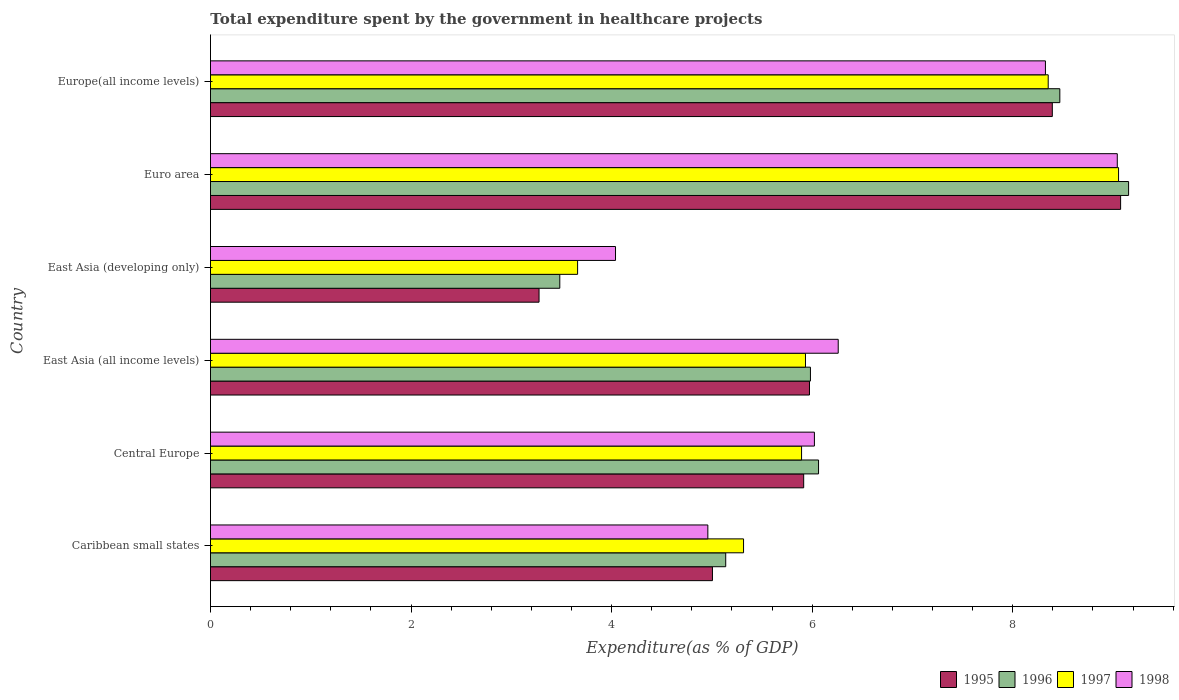How many different coloured bars are there?
Your answer should be very brief. 4. How many groups of bars are there?
Provide a short and direct response. 6. Are the number of bars per tick equal to the number of legend labels?
Your answer should be compact. Yes. How many bars are there on the 4th tick from the top?
Your answer should be very brief. 4. What is the label of the 5th group of bars from the top?
Offer a very short reply. Central Europe. In how many cases, is the number of bars for a given country not equal to the number of legend labels?
Your answer should be compact. 0. What is the total expenditure spent by the government in healthcare projects in 1998 in Euro area?
Give a very brief answer. 9.04. Across all countries, what is the maximum total expenditure spent by the government in healthcare projects in 1995?
Ensure brevity in your answer.  9.08. Across all countries, what is the minimum total expenditure spent by the government in healthcare projects in 1998?
Your response must be concise. 4.04. In which country was the total expenditure spent by the government in healthcare projects in 1995 maximum?
Provide a short and direct response. Euro area. In which country was the total expenditure spent by the government in healthcare projects in 1996 minimum?
Keep it short and to the point. East Asia (developing only). What is the total total expenditure spent by the government in healthcare projects in 1997 in the graph?
Offer a terse response. 38.21. What is the difference between the total expenditure spent by the government in healthcare projects in 1997 in Caribbean small states and that in East Asia (all income levels)?
Provide a short and direct response. -0.62. What is the difference between the total expenditure spent by the government in healthcare projects in 1995 in Central Europe and the total expenditure spent by the government in healthcare projects in 1996 in Europe(all income levels)?
Your answer should be compact. -2.55. What is the average total expenditure spent by the government in healthcare projects in 1996 per country?
Offer a terse response. 6.38. What is the difference between the total expenditure spent by the government in healthcare projects in 1995 and total expenditure spent by the government in healthcare projects in 1998 in East Asia (developing only)?
Provide a succinct answer. -0.76. What is the ratio of the total expenditure spent by the government in healthcare projects in 1996 in Central Europe to that in Euro area?
Your response must be concise. 0.66. What is the difference between the highest and the second highest total expenditure spent by the government in healthcare projects in 1997?
Offer a very short reply. 0.7. What is the difference between the highest and the lowest total expenditure spent by the government in healthcare projects in 1995?
Offer a very short reply. 5.8. In how many countries, is the total expenditure spent by the government in healthcare projects in 1995 greater than the average total expenditure spent by the government in healthcare projects in 1995 taken over all countries?
Provide a succinct answer. 2. What does the 4th bar from the top in East Asia (all income levels) represents?
Your answer should be compact. 1995. What does the 4th bar from the bottom in East Asia (all income levels) represents?
Your answer should be very brief. 1998. Does the graph contain grids?
Your answer should be very brief. No. Where does the legend appear in the graph?
Provide a short and direct response. Bottom right. How are the legend labels stacked?
Offer a very short reply. Horizontal. What is the title of the graph?
Your response must be concise. Total expenditure spent by the government in healthcare projects. What is the label or title of the X-axis?
Your response must be concise. Expenditure(as % of GDP). What is the Expenditure(as % of GDP) in 1995 in Caribbean small states?
Ensure brevity in your answer.  5.01. What is the Expenditure(as % of GDP) of 1996 in Caribbean small states?
Give a very brief answer. 5.14. What is the Expenditure(as % of GDP) of 1997 in Caribbean small states?
Give a very brief answer. 5.32. What is the Expenditure(as % of GDP) in 1998 in Caribbean small states?
Offer a terse response. 4.96. What is the Expenditure(as % of GDP) in 1995 in Central Europe?
Keep it short and to the point. 5.92. What is the Expenditure(as % of GDP) of 1996 in Central Europe?
Give a very brief answer. 6.06. What is the Expenditure(as % of GDP) in 1997 in Central Europe?
Offer a terse response. 5.89. What is the Expenditure(as % of GDP) of 1998 in Central Europe?
Make the answer very short. 6.02. What is the Expenditure(as % of GDP) of 1995 in East Asia (all income levels)?
Your response must be concise. 5.97. What is the Expenditure(as % of GDP) of 1996 in East Asia (all income levels)?
Make the answer very short. 5.98. What is the Expenditure(as % of GDP) of 1997 in East Asia (all income levels)?
Give a very brief answer. 5.93. What is the Expenditure(as % of GDP) of 1998 in East Asia (all income levels)?
Provide a succinct answer. 6.26. What is the Expenditure(as % of GDP) of 1995 in East Asia (developing only)?
Your answer should be compact. 3.28. What is the Expenditure(as % of GDP) of 1996 in East Asia (developing only)?
Offer a very short reply. 3.48. What is the Expenditure(as % of GDP) in 1997 in East Asia (developing only)?
Your answer should be very brief. 3.66. What is the Expenditure(as % of GDP) of 1998 in East Asia (developing only)?
Your answer should be very brief. 4.04. What is the Expenditure(as % of GDP) in 1995 in Euro area?
Make the answer very short. 9.08. What is the Expenditure(as % of GDP) of 1996 in Euro area?
Provide a short and direct response. 9.16. What is the Expenditure(as % of GDP) in 1997 in Euro area?
Ensure brevity in your answer.  9.06. What is the Expenditure(as % of GDP) in 1998 in Euro area?
Give a very brief answer. 9.04. What is the Expenditure(as % of GDP) of 1995 in Europe(all income levels)?
Offer a very short reply. 8.39. What is the Expenditure(as % of GDP) in 1996 in Europe(all income levels)?
Give a very brief answer. 8.47. What is the Expenditure(as % of GDP) in 1997 in Europe(all income levels)?
Offer a terse response. 8.35. What is the Expenditure(as % of GDP) of 1998 in Europe(all income levels)?
Your response must be concise. 8.33. Across all countries, what is the maximum Expenditure(as % of GDP) in 1995?
Provide a short and direct response. 9.08. Across all countries, what is the maximum Expenditure(as % of GDP) in 1996?
Your response must be concise. 9.16. Across all countries, what is the maximum Expenditure(as % of GDP) in 1997?
Your response must be concise. 9.06. Across all countries, what is the maximum Expenditure(as % of GDP) in 1998?
Offer a very short reply. 9.04. Across all countries, what is the minimum Expenditure(as % of GDP) of 1995?
Offer a very short reply. 3.28. Across all countries, what is the minimum Expenditure(as % of GDP) in 1996?
Provide a short and direct response. 3.48. Across all countries, what is the minimum Expenditure(as % of GDP) in 1997?
Provide a succinct answer. 3.66. Across all countries, what is the minimum Expenditure(as % of GDP) in 1998?
Offer a very short reply. 4.04. What is the total Expenditure(as % of GDP) of 1995 in the graph?
Offer a terse response. 37.64. What is the total Expenditure(as % of GDP) in 1996 in the graph?
Your response must be concise. 38.29. What is the total Expenditure(as % of GDP) in 1997 in the graph?
Your answer should be very brief. 38.21. What is the total Expenditure(as % of GDP) of 1998 in the graph?
Offer a terse response. 38.65. What is the difference between the Expenditure(as % of GDP) in 1995 in Caribbean small states and that in Central Europe?
Provide a short and direct response. -0.91. What is the difference between the Expenditure(as % of GDP) of 1996 in Caribbean small states and that in Central Europe?
Ensure brevity in your answer.  -0.93. What is the difference between the Expenditure(as % of GDP) of 1997 in Caribbean small states and that in Central Europe?
Ensure brevity in your answer.  -0.58. What is the difference between the Expenditure(as % of GDP) in 1998 in Caribbean small states and that in Central Europe?
Ensure brevity in your answer.  -1.06. What is the difference between the Expenditure(as % of GDP) in 1995 in Caribbean small states and that in East Asia (all income levels)?
Provide a short and direct response. -0.97. What is the difference between the Expenditure(as % of GDP) in 1996 in Caribbean small states and that in East Asia (all income levels)?
Give a very brief answer. -0.84. What is the difference between the Expenditure(as % of GDP) of 1997 in Caribbean small states and that in East Asia (all income levels)?
Your answer should be compact. -0.62. What is the difference between the Expenditure(as % of GDP) of 1998 in Caribbean small states and that in East Asia (all income levels)?
Offer a very short reply. -1.3. What is the difference between the Expenditure(as % of GDP) of 1995 in Caribbean small states and that in East Asia (developing only)?
Provide a short and direct response. 1.73. What is the difference between the Expenditure(as % of GDP) in 1996 in Caribbean small states and that in East Asia (developing only)?
Your answer should be compact. 1.65. What is the difference between the Expenditure(as % of GDP) in 1997 in Caribbean small states and that in East Asia (developing only)?
Ensure brevity in your answer.  1.65. What is the difference between the Expenditure(as % of GDP) in 1998 in Caribbean small states and that in East Asia (developing only)?
Make the answer very short. 0.92. What is the difference between the Expenditure(as % of GDP) of 1995 in Caribbean small states and that in Euro area?
Your response must be concise. -4.07. What is the difference between the Expenditure(as % of GDP) of 1996 in Caribbean small states and that in Euro area?
Your response must be concise. -4.02. What is the difference between the Expenditure(as % of GDP) of 1997 in Caribbean small states and that in Euro area?
Ensure brevity in your answer.  -3.74. What is the difference between the Expenditure(as % of GDP) of 1998 in Caribbean small states and that in Euro area?
Keep it short and to the point. -4.08. What is the difference between the Expenditure(as % of GDP) of 1995 in Caribbean small states and that in Europe(all income levels)?
Give a very brief answer. -3.39. What is the difference between the Expenditure(as % of GDP) in 1996 in Caribbean small states and that in Europe(all income levels)?
Give a very brief answer. -3.33. What is the difference between the Expenditure(as % of GDP) of 1997 in Caribbean small states and that in Europe(all income levels)?
Provide a succinct answer. -3.04. What is the difference between the Expenditure(as % of GDP) in 1998 in Caribbean small states and that in Europe(all income levels)?
Give a very brief answer. -3.37. What is the difference between the Expenditure(as % of GDP) of 1995 in Central Europe and that in East Asia (all income levels)?
Your answer should be very brief. -0.06. What is the difference between the Expenditure(as % of GDP) in 1996 in Central Europe and that in East Asia (all income levels)?
Offer a very short reply. 0.08. What is the difference between the Expenditure(as % of GDP) of 1997 in Central Europe and that in East Asia (all income levels)?
Give a very brief answer. -0.04. What is the difference between the Expenditure(as % of GDP) of 1998 in Central Europe and that in East Asia (all income levels)?
Provide a short and direct response. -0.24. What is the difference between the Expenditure(as % of GDP) of 1995 in Central Europe and that in East Asia (developing only)?
Offer a very short reply. 2.64. What is the difference between the Expenditure(as % of GDP) in 1996 in Central Europe and that in East Asia (developing only)?
Ensure brevity in your answer.  2.58. What is the difference between the Expenditure(as % of GDP) of 1997 in Central Europe and that in East Asia (developing only)?
Provide a short and direct response. 2.23. What is the difference between the Expenditure(as % of GDP) of 1998 in Central Europe and that in East Asia (developing only)?
Provide a short and direct response. 1.98. What is the difference between the Expenditure(as % of GDP) in 1995 in Central Europe and that in Euro area?
Offer a very short reply. -3.16. What is the difference between the Expenditure(as % of GDP) in 1996 in Central Europe and that in Euro area?
Offer a very short reply. -3.09. What is the difference between the Expenditure(as % of GDP) in 1997 in Central Europe and that in Euro area?
Keep it short and to the point. -3.16. What is the difference between the Expenditure(as % of GDP) in 1998 in Central Europe and that in Euro area?
Your answer should be compact. -3.02. What is the difference between the Expenditure(as % of GDP) of 1995 in Central Europe and that in Europe(all income levels)?
Provide a short and direct response. -2.48. What is the difference between the Expenditure(as % of GDP) in 1996 in Central Europe and that in Europe(all income levels)?
Your answer should be compact. -2.41. What is the difference between the Expenditure(as % of GDP) in 1997 in Central Europe and that in Europe(all income levels)?
Offer a very short reply. -2.46. What is the difference between the Expenditure(as % of GDP) in 1998 in Central Europe and that in Europe(all income levels)?
Give a very brief answer. -2.3. What is the difference between the Expenditure(as % of GDP) of 1995 in East Asia (all income levels) and that in East Asia (developing only)?
Provide a short and direct response. 2.7. What is the difference between the Expenditure(as % of GDP) in 1996 in East Asia (all income levels) and that in East Asia (developing only)?
Offer a very short reply. 2.5. What is the difference between the Expenditure(as % of GDP) of 1997 in East Asia (all income levels) and that in East Asia (developing only)?
Your answer should be very brief. 2.27. What is the difference between the Expenditure(as % of GDP) of 1998 in East Asia (all income levels) and that in East Asia (developing only)?
Give a very brief answer. 2.22. What is the difference between the Expenditure(as % of GDP) of 1995 in East Asia (all income levels) and that in Euro area?
Your response must be concise. -3.1. What is the difference between the Expenditure(as % of GDP) in 1996 in East Asia (all income levels) and that in Euro area?
Offer a very short reply. -3.17. What is the difference between the Expenditure(as % of GDP) of 1997 in East Asia (all income levels) and that in Euro area?
Provide a short and direct response. -3.12. What is the difference between the Expenditure(as % of GDP) of 1998 in East Asia (all income levels) and that in Euro area?
Ensure brevity in your answer.  -2.78. What is the difference between the Expenditure(as % of GDP) in 1995 in East Asia (all income levels) and that in Europe(all income levels)?
Give a very brief answer. -2.42. What is the difference between the Expenditure(as % of GDP) of 1996 in East Asia (all income levels) and that in Europe(all income levels)?
Offer a terse response. -2.49. What is the difference between the Expenditure(as % of GDP) in 1997 in East Asia (all income levels) and that in Europe(all income levels)?
Offer a terse response. -2.42. What is the difference between the Expenditure(as % of GDP) of 1998 in East Asia (all income levels) and that in Europe(all income levels)?
Your answer should be compact. -2.07. What is the difference between the Expenditure(as % of GDP) in 1995 in East Asia (developing only) and that in Euro area?
Ensure brevity in your answer.  -5.8. What is the difference between the Expenditure(as % of GDP) in 1996 in East Asia (developing only) and that in Euro area?
Your answer should be compact. -5.67. What is the difference between the Expenditure(as % of GDP) of 1997 in East Asia (developing only) and that in Euro area?
Your response must be concise. -5.39. What is the difference between the Expenditure(as % of GDP) in 1998 in East Asia (developing only) and that in Euro area?
Provide a short and direct response. -5. What is the difference between the Expenditure(as % of GDP) of 1995 in East Asia (developing only) and that in Europe(all income levels)?
Give a very brief answer. -5.12. What is the difference between the Expenditure(as % of GDP) of 1996 in East Asia (developing only) and that in Europe(all income levels)?
Offer a very short reply. -4.99. What is the difference between the Expenditure(as % of GDP) in 1997 in East Asia (developing only) and that in Europe(all income levels)?
Keep it short and to the point. -4.69. What is the difference between the Expenditure(as % of GDP) in 1998 in East Asia (developing only) and that in Europe(all income levels)?
Offer a very short reply. -4.29. What is the difference between the Expenditure(as % of GDP) in 1995 in Euro area and that in Europe(all income levels)?
Your answer should be very brief. 0.68. What is the difference between the Expenditure(as % of GDP) in 1996 in Euro area and that in Europe(all income levels)?
Make the answer very short. 0.69. What is the difference between the Expenditure(as % of GDP) in 1997 in Euro area and that in Europe(all income levels)?
Offer a very short reply. 0.7. What is the difference between the Expenditure(as % of GDP) of 1998 in Euro area and that in Europe(all income levels)?
Provide a succinct answer. 0.72. What is the difference between the Expenditure(as % of GDP) of 1995 in Caribbean small states and the Expenditure(as % of GDP) of 1996 in Central Europe?
Provide a succinct answer. -1.06. What is the difference between the Expenditure(as % of GDP) of 1995 in Caribbean small states and the Expenditure(as % of GDP) of 1997 in Central Europe?
Make the answer very short. -0.89. What is the difference between the Expenditure(as % of GDP) in 1995 in Caribbean small states and the Expenditure(as % of GDP) in 1998 in Central Europe?
Offer a terse response. -1.02. What is the difference between the Expenditure(as % of GDP) in 1996 in Caribbean small states and the Expenditure(as % of GDP) in 1997 in Central Europe?
Provide a short and direct response. -0.76. What is the difference between the Expenditure(as % of GDP) of 1996 in Caribbean small states and the Expenditure(as % of GDP) of 1998 in Central Europe?
Make the answer very short. -0.88. What is the difference between the Expenditure(as % of GDP) in 1997 in Caribbean small states and the Expenditure(as % of GDP) in 1998 in Central Europe?
Offer a terse response. -0.71. What is the difference between the Expenditure(as % of GDP) of 1995 in Caribbean small states and the Expenditure(as % of GDP) of 1996 in East Asia (all income levels)?
Your answer should be very brief. -0.98. What is the difference between the Expenditure(as % of GDP) of 1995 in Caribbean small states and the Expenditure(as % of GDP) of 1997 in East Asia (all income levels)?
Provide a short and direct response. -0.93. What is the difference between the Expenditure(as % of GDP) of 1995 in Caribbean small states and the Expenditure(as % of GDP) of 1998 in East Asia (all income levels)?
Ensure brevity in your answer.  -1.25. What is the difference between the Expenditure(as % of GDP) in 1996 in Caribbean small states and the Expenditure(as % of GDP) in 1997 in East Asia (all income levels)?
Provide a succinct answer. -0.8. What is the difference between the Expenditure(as % of GDP) in 1996 in Caribbean small states and the Expenditure(as % of GDP) in 1998 in East Asia (all income levels)?
Give a very brief answer. -1.12. What is the difference between the Expenditure(as % of GDP) of 1997 in Caribbean small states and the Expenditure(as % of GDP) of 1998 in East Asia (all income levels)?
Keep it short and to the point. -0.94. What is the difference between the Expenditure(as % of GDP) of 1995 in Caribbean small states and the Expenditure(as % of GDP) of 1996 in East Asia (developing only)?
Make the answer very short. 1.52. What is the difference between the Expenditure(as % of GDP) of 1995 in Caribbean small states and the Expenditure(as % of GDP) of 1997 in East Asia (developing only)?
Offer a terse response. 1.34. What is the difference between the Expenditure(as % of GDP) of 1995 in Caribbean small states and the Expenditure(as % of GDP) of 1998 in East Asia (developing only)?
Your answer should be compact. 0.97. What is the difference between the Expenditure(as % of GDP) in 1996 in Caribbean small states and the Expenditure(as % of GDP) in 1997 in East Asia (developing only)?
Give a very brief answer. 1.48. What is the difference between the Expenditure(as % of GDP) of 1996 in Caribbean small states and the Expenditure(as % of GDP) of 1998 in East Asia (developing only)?
Make the answer very short. 1.1. What is the difference between the Expenditure(as % of GDP) of 1997 in Caribbean small states and the Expenditure(as % of GDP) of 1998 in East Asia (developing only)?
Provide a succinct answer. 1.28. What is the difference between the Expenditure(as % of GDP) of 1995 in Caribbean small states and the Expenditure(as % of GDP) of 1996 in Euro area?
Offer a very short reply. -4.15. What is the difference between the Expenditure(as % of GDP) in 1995 in Caribbean small states and the Expenditure(as % of GDP) in 1997 in Euro area?
Your answer should be compact. -4.05. What is the difference between the Expenditure(as % of GDP) of 1995 in Caribbean small states and the Expenditure(as % of GDP) of 1998 in Euro area?
Offer a very short reply. -4.04. What is the difference between the Expenditure(as % of GDP) of 1996 in Caribbean small states and the Expenditure(as % of GDP) of 1997 in Euro area?
Provide a short and direct response. -3.92. What is the difference between the Expenditure(as % of GDP) in 1996 in Caribbean small states and the Expenditure(as % of GDP) in 1998 in Euro area?
Give a very brief answer. -3.9. What is the difference between the Expenditure(as % of GDP) in 1997 in Caribbean small states and the Expenditure(as % of GDP) in 1998 in Euro area?
Your response must be concise. -3.73. What is the difference between the Expenditure(as % of GDP) of 1995 in Caribbean small states and the Expenditure(as % of GDP) of 1996 in Europe(all income levels)?
Provide a short and direct response. -3.46. What is the difference between the Expenditure(as % of GDP) of 1995 in Caribbean small states and the Expenditure(as % of GDP) of 1997 in Europe(all income levels)?
Keep it short and to the point. -3.35. What is the difference between the Expenditure(as % of GDP) in 1995 in Caribbean small states and the Expenditure(as % of GDP) in 1998 in Europe(all income levels)?
Provide a short and direct response. -3.32. What is the difference between the Expenditure(as % of GDP) in 1996 in Caribbean small states and the Expenditure(as % of GDP) in 1997 in Europe(all income levels)?
Provide a succinct answer. -3.22. What is the difference between the Expenditure(as % of GDP) in 1996 in Caribbean small states and the Expenditure(as % of GDP) in 1998 in Europe(all income levels)?
Make the answer very short. -3.19. What is the difference between the Expenditure(as % of GDP) in 1997 in Caribbean small states and the Expenditure(as % of GDP) in 1998 in Europe(all income levels)?
Offer a very short reply. -3.01. What is the difference between the Expenditure(as % of GDP) in 1995 in Central Europe and the Expenditure(as % of GDP) in 1996 in East Asia (all income levels)?
Your answer should be very brief. -0.07. What is the difference between the Expenditure(as % of GDP) of 1995 in Central Europe and the Expenditure(as % of GDP) of 1997 in East Asia (all income levels)?
Make the answer very short. -0.02. What is the difference between the Expenditure(as % of GDP) in 1995 in Central Europe and the Expenditure(as % of GDP) in 1998 in East Asia (all income levels)?
Ensure brevity in your answer.  -0.34. What is the difference between the Expenditure(as % of GDP) of 1996 in Central Europe and the Expenditure(as % of GDP) of 1997 in East Asia (all income levels)?
Give a very brief answer. 0.13. What is the difference between the Expenditure(as % of GDP) of 1996 in Central Europe and the Expenditure(as % of GDP) of 1998 in East Asia (all income levels)?
Provide a succinct answer. -0.2. What is the difference between the Expenditure(as % of GDP) of 1997 in Central Europe and the Expenditure(as % of GDP) of 1998 in East Asia (all income levels)?
Offer a very short reply. -0.37. What is the difference between the Expenditure(as % of GDP) of 1995 in Central Europe and the Expenditure(as % of GDP) of 1996 in East Asia (developing only)?
Offer a very short reply. 2.43. What is the difference between the Expenditure(as % of GDP) of 1995 in Central Europe and the Expenditure(as % of GDP) of 1997 in East Asia (developing only)?
Provide a short and direct response. 2.25. What is the difference between the Expenditure(as % of GDP) in 1995 in Central Europe and the Expenditure(as % of GDP) in 1998 in East Asia (developing only)?
Your response must be concise. 1.88. What is the difference between the Expenditure(as % of GDP) in 1996 in Central Europe and the Expenditure(as % of GDP) in 1997 in East Asia (developing only)?
Your answer should be very brief. 2.4. What is the difference between the Expenditure(as % of GDP) in 1996 in Central Europe and the Expenditure(as % of GDP) in 1998 in East Asia (developing only)?
Provide a succinct answer. 2.02. What is the difference between the Expenditure(as % of GDP) of 1997 in Central Europe and the Expenditure(as % of GDP) of 1998 in East Asia (developing only)?
Your response must be concise. 1.86. What is the difference between the Expenditure(as % of GDP) of 1995 in Central Europe and the Expenditure(as % of GDP) of 1996 in Euro area?
Ensure brevity in your answer.  -3.24. What is the difference between the Expenditure(as % of GDP) of 1995 in Central Europe and the Expenditure(as % of GDP) of 1997 in Euro area?
Offer a very short reply. -3.14. What is the difference between the Expenditure(as % of GDP) of 1995 in Central Europe and the Expenditure(as % of GDP) of 1998 in Euro area?
Offer a terse response. -3.13. What is the difference between the Expenditure(as % of GDP) in 1996 in Central Europe and the Expenditure(as % of GDP) in 1997 in Euro area?
Offer a terse response. -2.99. What is the difference between the Expenditure(as % of GDP) of 1996 in Central Europe and the Expenditure(as % of GDP) of 1998 in Euro area?
Your answer should be compact. -2.98. What is the difference between the Expenditure(as % of GDP) of 1997 in Central Europe and the Expenditure(as % of GDP) of 1998 in Euro area?
Offer a terse response. -3.15. What is the difference between the Expenditure(as % of GDP) of 1995 in Central Europe and the Expenditure(as % of GDP) of 1996 in Europe(all income levels)?
Make the answer very short. -2.55. What is the difference between the Expenditure(as % of GDP) in 1995 in Central Europe and the Expenditure(as % of GDP) in 1997 in Europe(all income levels)?
Offer a very short reply. -2.44. What is the difference between the Expenditure(as % of GDP) of 1995 in Central Europe and the Expenditure(as % of GDP) of 1998 in Europe(all income levels)?
Your answer should be very brief. -2.41. What is the difference between the Expenditure(as % of GDP) of 1996 in Central Europe and the Expenditure(as % of GDP) of 1997 in Europe(all income levels)?
Provide a short and direct response. -2.29. What is the difference between the Expenditure(as % of GDP) in 1996 in Central Europe and the Expenditure(as % of GDP) in 1998 in Europe(all income levels)?
Ensure brevity in your answer.  -2.26. What is the difference between the Expenditure(as % of GDP) of 1997 in Central Europe and the Expenditure(as % of GDP) of 1998 in Europe(all income levels)?
Your answer should be compact. -2.43. What is the difference between the Expenditure(as % of GDP) of 1995 in East Asia (all income levels) and the Expenditure(as % of GDP) of 1996 in East Asia (developing only)?
Keep it short and to the point. 2.49. What is the difference between the Expenditure(as % of GDP) of 1995 in East Asia (all income levels) and the Expenditure(as % of GDP) of 1997 in East Asia (developing only)?
Make the answer very short. 2.31. What is the difference between the Expenditure(as % of GDP) of 1995 in East Asia (all income levels) and the Expenditure(as % of GDP) of 1998 in East Asia (developing only)?
Offer a very short reply. 1.93. What is the difference between the Expenditure(as % of GDP) of 1996 in East Asia (all income levels) and the Expenditure(as % of GDP) of 1997 in East Asia (developing only)?
Your answer should be very brief. 2.32. What is the difference between the Expenditure(as % of GDP) of 1996 in East Asia (all income levels) and the Expenditure(as % of GDP) of 1998 in East Asia (developing only)?
Keep it short and to the point. 1.94. What is the difference between the Expenditure(as % of GDP) of 1997 in East Asia (all income levels) and the Expenditure(as % of GDP) of 1998 in East Asia (developing only)?
Give a very brief answer. 1.89. What is the difference between the Expenditure(as % of GDP) in 1995 in East Asia (all income levels) and the Expenditure(as % of GDP) in 1996 in Euro area?
Offer a very short reply. -3.18. What is the difference between the Expenditure(as % of GDP) of 1995 in East Asia (all income levels) and the Expenditure(as % of GDP) of 1997 in Euro area?
Provide a succinct answer. -3.08. What is the difference between the Expenditure(as % of GDP) in 1995 in East Asia (all income levels) and the Expenditure(as % of GDP) in 1998 in Euro area?
Offer a very short reply. -3.07. What is the difference between the Expenditure(as % of GDP) in 1996 in East Asia (all income levels) and the Expenditure(as % of GDP) in 1997 in Euro area?
Make the answer very short. -3.07. What is the difference between the Expenditure(as % of GDP) in 1996 in East Asia (all income levels) and the Expenditure(as % of GDP) in 1998 in Euro area?
Make the answer very short. -3.06. What is the difference between the Expenditure(as % of GDP) in 1997 in East Asia (all income levels) and the Expenditure(as % of GDP) in 1998 in Euro area?
Your answer should be compact. -3.11. What is the difference between the Expenditure(as % of GDP) of 1995 in East Asia (all income levels) and the Expenditure(as % of GDP) of 1996 in Europe(all income levels)?
Keep it short and to the point. -2.5. What is the difference between the Expenditure(as % of GDP) in 1995 in East Asia (all income levels) and the Expenditure(as % of GDP) in 1997 in Europe(all income levels)?
Your response must be concise. -2.38. What is the difference between the Expenditure(as % of GDP) in 1995 in East Asia (all income levels) and the Expenditure(as % of GDP) in 1998 in Europe(all income levels)?
Keep it short and to the point. -2.35. What is the difference between the Expenditure(as % of GDP) of 1996 in East Asia (all income levels) and the Expenditure(as % of GDP) of 1997 in Europe(all income levels)?
Offer a terse response. -2.37. What is the difference between the Expenditure(as % of GDP) of 1996 in East Asia (all income levels) and the Expenditure(as % of GDP) of 1998 in Europe(all income levels)?
Your answer should be very brief. -2.34. What is the difference between the Expenditure(as % of GDP) of 1997 in East Asia (all income levels) and the Expenditure(as % of GDP) of 1998 in Europe(all income levels)?
Make the answer very short. -2.39. What is the difference between the Expenditure(as % of GDP) of 1995 in East Asia (developing only) and the Expenditure(as % of GDP) of 1996 in Euro area?
Give a very brief answer. -5.88. What is the difference between the Expenditure(as % of GDP) of 1995 in East Asia (developing only) and the Expenditure(as % of GDP) of 1997 in Euro area?
Give a very brief answer. -5.78. What is the difference between the Expenditure(as % of GDP) in 1995 in East Asia (developing only) and the Expenditure(as % of GDP) in 1998 in Euro area?
Provide a short and direct response. -5.77. What is the difference between the Expenditure(as % of GDP) of 1996 in East Asia (developing only) and the Expenditure(as % of GDP) of 1997 in Euro area?
Ensure brevity in your answer.  -5.57. What is the difference between the Expenditure(as % of GDP) in 1996 in East Asia (developing only) and the Expenditure(as % of GDP) in 1998 in Euro area?
Provide a short and direct response. -5.56. What is the difference between the Expenditure(as % of GDP) in 1997 in East Asia (developing only) and the Expenditure(as % of GDP) in 1998 in Euro area?
Give a very brief answer. -5.38. What is the difference between the Expenditure(as % of GDP) of 1995 in East Asia (developing only) and the Expenditure(as % of GDP) of 1996 in Europe(all income levels)?
Give a very brief answer. -5.19. What is the difference between the Expenditure(as % of GDP) in 1995 in East Asia (developing only) and the Expenditure(as % of GDP) in 1997 in Europe(all income levels)?
Provide a short and direct response. -5.08. What is the difference between the Expenditure(as % of GDP) in 1995 in East Asia (developing only) and the Expenditure(as % of GDP) in 1998 in Europe(all income levels)?
Give a very brief answer. -5.05. What is the difference between the Expenditure(as % of GDP) of 1996 in East Asia (developing only) and the Expenditure(as % of GDP) of 1997 in Europe(all income levels)?
Ensure brevity in your answer.  -4.87. What is the difference between the Expenditure(as % of GDP) of 1996 in East Asia (developing only) and the Expenditure(as % of GDP) of 1998 in Europe(all income levels)?
Your response must be concise. -4.84. What is the difference between the Expenditure(as % of GDP) of 1997 in East Asia (developing only) and the Expenditure(as % of GDP) of 1998 in Europe(all income levels)?
Provide a succinct answer. -4.67. What is the difference between the Expenditure(as % of GDP) of 1995 in Euro area and the Expenditure(as % of GDP) of 1996 in Europe(all income levels)?
Your response must be concise. 0.61. What is the difference between the Expenditure(as % of GDP) in 1995 in Euro area and the Expenditure(as % of GDP) in 1997 in Europe(all income levels)?
Provide a short and direct response. 0.72. What is the difference between the Expenditure(as % of GDP) in 1995 in Euro area and the Expenditure(as % of GDP) in 1998 in Europe(all income levels)?
Provide a succinct answer. 0.75. What is the difference between the Expenditure(as % of GDP) of 1996 in Euro area and the Expenditure(as % of GDP) of 1997 in Europe(all income levels)?
Give a very brief answer. 0.8. What is the difference between the Expenditure(as % of GDP) in 1996 in Euro area and the Expenditure(as % of GDP) in 1998 in Europe(all income levels)?
Your response must be concise. 0.83. What is the difference between the Expenditure(as % of GDP) of 1997 in Euro area and the Expenditure(as % of GDP) of 1998 in Europe(all income levels)?
Offer a very short reply. 0.73. What is the average Expenditure(as % of GDP) in 1995 per country?
Provide a short and direct response. 6.27. What is the average Expenditure(as % of GDP) in 1996 per country?
Your response must be concise. 6.38. What is the average Expenditure(as % of GDP) of 1997 per country?
Offer a terse response. 6.37. What is the average Expenditure(as % of GDP) in 1998 per country?
Give a very brief answer. 6.44. What is the difference between the Expenditure(as % of GDP) of 1995 and Expenditure(as % of GDP) of 1996 in Caribbean small states?
Provide a short and direct response. -0.13. What is the difference between the Expenditure(as % of GDP) of 1995 and Expenditure(as % of GDP) of 1997 in Caribbean small states?
Keep it short and to the point. -0.31. What is the difference between the Expenditure(as % of GDP) of 1995 and Expenditure(as % of GDP) of 1998 in Caribbean small states?
Give a very brief answer. 0.05. What is the difference between the Expenditure(as % of GDP) in 1996 and Expenditure(as % of GDP) in 1997 in Caribbean small states?
Make the answer very short. -0.18. What is the difference between the Expenditure(as % of GDP) in 1996 and Expenditure(as % of GDP) in 1998 in Caribbean small states?
Provide a succinct answer. 0.18. What is the difference between the Expenditure(as % of GDP) in 1997 and Expenditure(as % of GDP) in 1998 in Caribbean small states?
Give a very brief answer. 0.36. What is the difference between the Expenditure(as % of GDP) in 1995 and Expenditure(as % of GDP) in 1996 in Central Europe?
Your answer should be compact. -0.15. What is the difference between the Expenditure(as % of GDP) of 1995 and Expenditure(as % of GDP) of 1997 in Central Europe?
Your answer should be compact. 0.02. What is the difference between the Expenditure(as % of GDP) in 1995 and Expenditure(as % of GDP) in 1998 in Central Europe?
Ensure brevity in your answer.  -0.11. What is the difference between the Expenditure(as % of GDP) in 1996 and Expenditure(as % of GDP) in 1997 in Central Europe?
Ensure brevity in your answer.  0.17. What is the difference between the Expenditure(as % of GDP) of 1996 and Expenditure(as % of GDP) of 1998 in Central Europe?
Make the answer very short. 0.04. What is the difference between the Expenditure(as % of GDP) of 1997 and Expenditure(as % of GDP) of 1998 in Central Europe?
Offer a very short reply. -0.13. What is the difference between the Expenditure(as % of GDP) of 1995 and Expenditure(as % of GDP) of 1996 in East Asia (all income levels)?
Offer a very short reply. -0.01. What is the difference between the Expenditure(as % of GDP) in 1995 and Expenditure(as % of GDP) in 1997 in East Asia (all income levels)?
Your response must be concise. 0.04. What is the difference between the Expenditure(as % of GDP) in 1995 and Expenditure(as % of GDP) in 1998 in East Asia (all income levels)?
Offer a very short reply. -0.29. What is the difference between the Expenditure(as % of GDP) of 1996 and Expenditure(as % of GDP) of 1997 in East Asia (all income levels)?
Your answer should be compact. 0.05. What is the difference between the Expenditure(as % of GDP) in 1996 and Expenditure(as % of GDP) in 1998 in East Asia (all income levels)?
Your answer should be compact. -0.28. What is the difference between the Expenditure(as % of GDP) of 1997 and Expenditure(as % of GDP) of 1998 in East Asia (all income levels)?
Give a very brief answer. -0.33. What is the difference between the Expenditure(as % of GDP) in 1995 and Expenditure(as % of GDP) in 1996 in East Asia (developing only)?
Give a very brief answer. -0.21. What is the difference between the Expenditure(as % of GDP) in 1995 and Expenditure(as % of GDP) in 1997 in East Asia (developing only)?
Offer a very short reply. -0.38. What is the difference between the Expenditure(as % of GDP) of 1995 and Expenditure(as % of GDP) of 1998 in East Asia (developing only)?
Offer a terse response. -0.76. What is the difference between the Expenditure(as % of GDP) in 1996 and Expenditure(as % of GDP) in 1997 in East Asia (developing only)?
Your response must be concise. -0.18. What is the difference between the Expenditure(as % of GDP) in 1996 and Expenditure(as % of GDP) in 1998 in East Asia (developing only)?
Make the answer very short. -0.56. What is the difference between the Expenditure(as % of GDP) of 1997 and Expenditure(as % of GDP) of 1998 in East Asia (developing only)?
Your answer should be very brief. -0.38. What is the difference between the Expenditure(as % of GDP) in 1995 and Expenditure(as % of GDP) in 1996 in Euro area?
Your response must be concise. -0.08. What is the difference between the Expenditure(as % of GDP) in 1995 and Expenditure(as % of GDP) in 1997 in Euro area?
Offer a very short reply. 0.02. What is the difference between the Expenditure(as % of GDP) in 1995 and Expenditure(as % of GDP) in 1998 in Euro area?
Ensure brevity in your answer.  0.03. What is the difference between the Expenditure(as % of GDP) in 1996 and Expenditure(as % of GDP) in 1997 in Euro area?
Provide a succinct answer. 0.1. What is the difference between the Expenditure(as % of GDP) of 1996 and Expenditure(as % of GDP) of 1998 in Euro area?
Offer a very short reply. 0.11. What is the difference between the Expenditure(as % of GDP) in 1997 and Expenditure(as % of GDP) in 1998 in Euro area?
Offer a terse response. 0.01. What is the difference between the Expenditure(as % of GDP) in 1995 and Expenditure(as % of GDP) in 1996 in Europe(all income levels)?
Provide a short and direct response. -0.07. What is the difference between the Expenditure(as % of GDP) of 1995 and Expenditure(as % of GDP) of 1997 in Europe(all income levels)?
Your answer should be compact. 0.04. What is the difference between the Expenditure(as % of GDP) of 1995 and Expenditure(as % of GDP) of 1998 in Europe(all income levels)?
Your answer should be very brief. 0.07. What is the difference between the Expenditure(as % of GDP) in 1996 and Expenditure(as % of GDP) in 1997 in Europe(all income levels)?
Keep it short and to the point. 0.12. What is the difference between the Expenditure(as % of GDP) of 1996 and Expenditure(as % of GDP) of 1998 in Europe(all income levels)?
Provide a short and direct response. 0.14. What is the difference between the Expenditure(as % of GDP) of 1997 and Expenditure(as % of GDP) of 1998 in Europe(all income levels)?
Provide a succinct answer. 0.03. What is the ratio of the Expenditure(as % of GDP) of 1995 in Caribbean small states to that in Central Europe?
Give a very brief answer. 0.85. What is the ratio of the Expenditure(as % of GDP) of 1996 in Caribbean small states to that in Central Europe?
Give a very brief answer. 0.85. What is the ratio of the Expenditure(as % of GDP) in 1997 in Caribbean small states to that in Central Europe?
Give a very brief answer. 0.9. What is the ratio of the Expenditure(as % of GDP) in 1998 in Caribbean small states to that in Central Europe?
Your answer should be very brief. 0.82. What is the ratio of the Expenditure(as % of GDP) of 1995 in Caribbean small states to that in East Asia (all income levels)?
Provide a succinct answer. 0.84. What is the ratio of the Expenditure(as % of GDP) of 1996 in Caribbean small states to that in East Asia (all income levels)?
Your answer should be very brief. 0.86. What is the ratio of the Expenditure(as % of GDP) in 1997 in Caribbean small states to that in East Asia (all income levels)?
Offer a terse response. 0.9. What is the ratio of the Expenditure(as % of GDP) of 1998 in Caribbean small states to that in East Asia (all income levels)?
Provide a short and direct response. 0.79. What is the ratio of the Expenditure(as % of GDP) in 1995 in Caribbean small states to that in East Asia (developing only)?
Your answer should be compact. 1.53. What is the ratio of the Expenditure(as % of GDP) in 1996 in Caribbean small states to that in East Asia (developing only)?
Offer a very short reply. 1.48. What is the ratio of the Expenditure(as % of GDP) in 1997 in Caribbean small states to that in East Asia (developing only)?
Provide a short and direct response. 1.45. What is the ratio of the Expenditure(as % of GDP) of 1998 in Caribbean small states to that in East Asia (developing only)?
Provide a short and direct response. 1.23. What is the ratio of the Expenditure(as % of GDP) in 1995 in Caribbean small states to that in Euro area?
Give a very brief answer. 0.55. What is the ratio of the Expenditure(as % of GDP) of 1996 in Caribbean small states to that in Euro area?
Give a very brief answer. 0.56. What is the ratio of the Expenditure(as % of GDP) in 1997 in Caribbean small states to that in Euro area?
Your response must be concise. 0.59. What is the ratio of the Expenditure(as % of GDP) of 1998 in Caribbean small states to that in Euro area?
Your answer should be very brief. 0.55. What is the ratio of the Expenditure(as % of GDP) in 1995 in Caribbean small states to that in Europe(all income levels)?
Keep it short and to the point. 0.6. What is the ratio of the Expenditure(as % of GDP) in 1996 in Caribbean small states to that in Europe(all income levels)?
Offer a very short reply. 0.61. What is the ratio of the Expenditure(as % of GDP) in 1997 in Caribbean small states to that in Europe(all income levels)?
Your response must be concise. 0.64. What is the ratio of the Expenditure(as % of GDP) in 1998 in Caribbean small states to that in Europe(all income levels)?
Provide a short and direct response. 0.6. What is the ratio of the Expenditure(as % of GDP) in 1995 in Central Europe to that in East Asia (all income levels)?
Provide a short and direct response. 0.99. What is the ratio of the Expenditure(as % of GDP) in 1996 in Central Europe to that in East Asia (all income levels)?
Give a very brief answer. 1.01. What is the ratio of the Expenditure(as % of GDP) of 1997 in Central Europe to that in East Asia (all income levels)?
Keep it short and to the point. 0.99. What is the ratio of the Expenditure(as % of GDP) of 1998 in Central Europe to that in East Asia (all income levels)?
Offer a very short reply. 0.96. What is the ratio of the Expenditure(as % of GDP) of 1995 in Central Europe to that in East Asia (developing only)?
Offer a terse response. 1.81. What is the ratio of the Expenditure(as % of GDP) in 1996 in Central Europe to that in East Asia (developing only)?
Ensure brevity in your answer.  1.74. What is the ratio of the Expenditure(as % of GDP) of 1997 in Central Europe to that in East Asia (developing only)?
Your answer should be very brief. 1.61. What is the ratio of the Expenditure(as % of GDP) in 1998 in Central Europe to that in East Asia (developing only)?
Your response must be concise. 1.49. What is the ratio of the Expenditure(as % of GDP) of 1995 in Central Europe to that in Euro area?
Ensure brevity in your answer.  0.65. What is the ratio of the Expenditure(as % of GDP) in 1996 in Central Europe to that in Euro area?
Keep it short and to the point. 0.66. What is the ratio of the Expenditure(as % of GDP) in 1997 in Central Europe to that in Euro area?
Your answer should be very brief. 0.65. What is the ratio of the Expenditure(as % of GDP) of 1998 in Central Europe to that in Euro area?
Provide a succinct answer. 0.67. What is the ratio of the Expenditure(as % of GDP) of 1995 in Central Europe to that in Europe(all income levels)?
Your response must be concise. 0.7. What is the ratio of the Expenditure(as % of GDP) of 1996 in Central Europe to that in Europe(all income levels)?
Keep it short and to the point. 0.72. What is the ratio of the Expenditure(as % of GDP) in 1997 in Central Europe to that in Europe(all income levels)?
Make the answer very short. 0.71. What is the ratio of the Expenditure(as % of GDP) of 1998 in Central Europe to that in Europe(all income levels)?
Give a very brief answer. 0.72. What is the ratio of the Expenditure(as % of GDP) in 1995 in East Asia (all income levels) to that in East Asia (developing only)?
Your answer should be very brief. 1.82. What is the ratio of the Expenditure(as % of GDP) of 1996 in East Asia (all income levels) to that in East Asia (developing only)?
Make the answer very short. 1.72. What is the ratio of the Expenditure(as % of GDP) of 1997 in East Asia (all income levels) to that in East Asia (developing only)?
Keep it short and to the point. 1.62. What is the ratio of the Expenditure(as % of GDP) in 1998 in East Asia (all income levels) to that in East Asia (developing only)?
Your answer should be compact. 1.55. What is the ratio of the Expenditure(as % of GDP) of 1995 in East Asia (all income levels) to that in Euro area?
Make the answer very short. 0.66. What is the ratio of the Expenditure(as % of GDP) of 1996 in East Asia (all income levels) to that in Euro area?
Keep it short and to the point. 0.65. What is the ratio of the Expenditure(as % of GDP) in 1997 in East Asia (all income levels) to that in Euro area?
Your answer should be very brief. 0.66. What is the ratio of the Expenditure(as % of GDP) of 1998 in East Asia (all income levels) to that in Euro area?
Keep it short and to the point. 0.69. What is the ratio of the Expenditure(as % of GDP) in 1995 in East Asia (all income levels) to that in Europe(all income levels)?
Offer a very short reply. 0.71. What is the ratio of the Expenditure(as % of GDP) in 1996 in East Asia (all income levels) to that in Europe(all income levels)?
Provide a succinct answer. 0.71. What is the ratio of the Expenditure(as % of GDP) in 1997 in East Asia (all income levels) to that in Europe(all income levels)?
Your response must be concise. 0.71. What is the ratio of the Expenditure(as % of GDP) of 1998 in East Asia (all income levels) to that in Europe(all income levels)?
Your answer should be very brief. 0.75. What is the ratio of the Expenditure(as % of GDP) in 1995 in East Asia (developing only) to that in Euro area?
Provide a succinct answer. 0.36. What is the ratio of the Expenditure(as % of GDP) of 1996 in East Asia (developing only) to that in Euro area?
Provide a short and direct response. 0.38. What is the ratio of the Expenditure(as % of GDP) of 1997 in East Asia (developing only) to that in Euro area?
Offer a terse response. 0.4. What is the ratio of the Expenditure(as % of GDP) in 1998 in East Asia (developing only) to that in Euro area?
Your answer should be compact. 0.45. What is the ratio of the Expenditure(as % of GDP) of 1995 in East Asia (developing only) to that in Europe(all income levels)?
Offer a terse response. 0.39. What is the ratio of the Expenditure(as % of GDP) in 1996 in East Asia (developing only) to that in Europe(all income levels)?
Provide a short and direct response. 0.41. What is the ratio of the Expenditure(as % of GDP) of 1997 in East Asia (developing only) to that in Europe(all income levels)?
Offer a terse response. 0.44. What is the ratio of the Expenditure(as % of GDP) of 1998 in East Asia (developing only) to that in Europe(all income levels)?
Offer a very short reply. 0.49. What is the ratio of the Expenditure(as % of GDP) in 1995 in Euro area to that in Europe(all income levels)?
Make the answer very short. 1.08. What is the ratio of the Expenditure(as % of GDP) in 1996 in Euro area to that in Europe(all income levels)?
Give a very brief answer. 1.08. What is the ratio of the Expenditure(as % of GDP) in 1997 in Euro area to that in Europe(all income levels)?
Your response must be concise. 1.08. What is the ratio of the Expenditure(as % of GDP) of 1998 in Euro area to that in Europe(all income levels)?
Make the answer very short. 1.09. What is the difference between the highest and the second highest Expenditure(as % of GDP) in 1995?
Ensure brevity in your answer.  0.68. What is the difference between the highest and the second highest Expenditure(as % of GDP) in 1996?
Your answer should be very brief. 0.69. What is the difference between the highest and the second highest Expenditure(as % of GDP) of 1997?
Keep it short and to the point. 0.7. What is the difference between the highest and the second highest Expenditure(as % of GDP) in 1998?
Your response must be concise. 0.72. What is the difference between the highest and the lowest Expenditure(as % of GDP) of 1995?
Your answer should be very brief. 5.8. What is the difference between the highest and the lowest Expenditure(as % of GDP) in 1996?
Make the answer very short. 5.67. What is the difference between the highest and the lowest Expenditure(as % of GDP) in 1997?
Keep it short and to the point. 5.39. What is the difference between the highest and the lowest Expenditure(as % of GDP) of 1998?
Offer a very short reply. 5. 